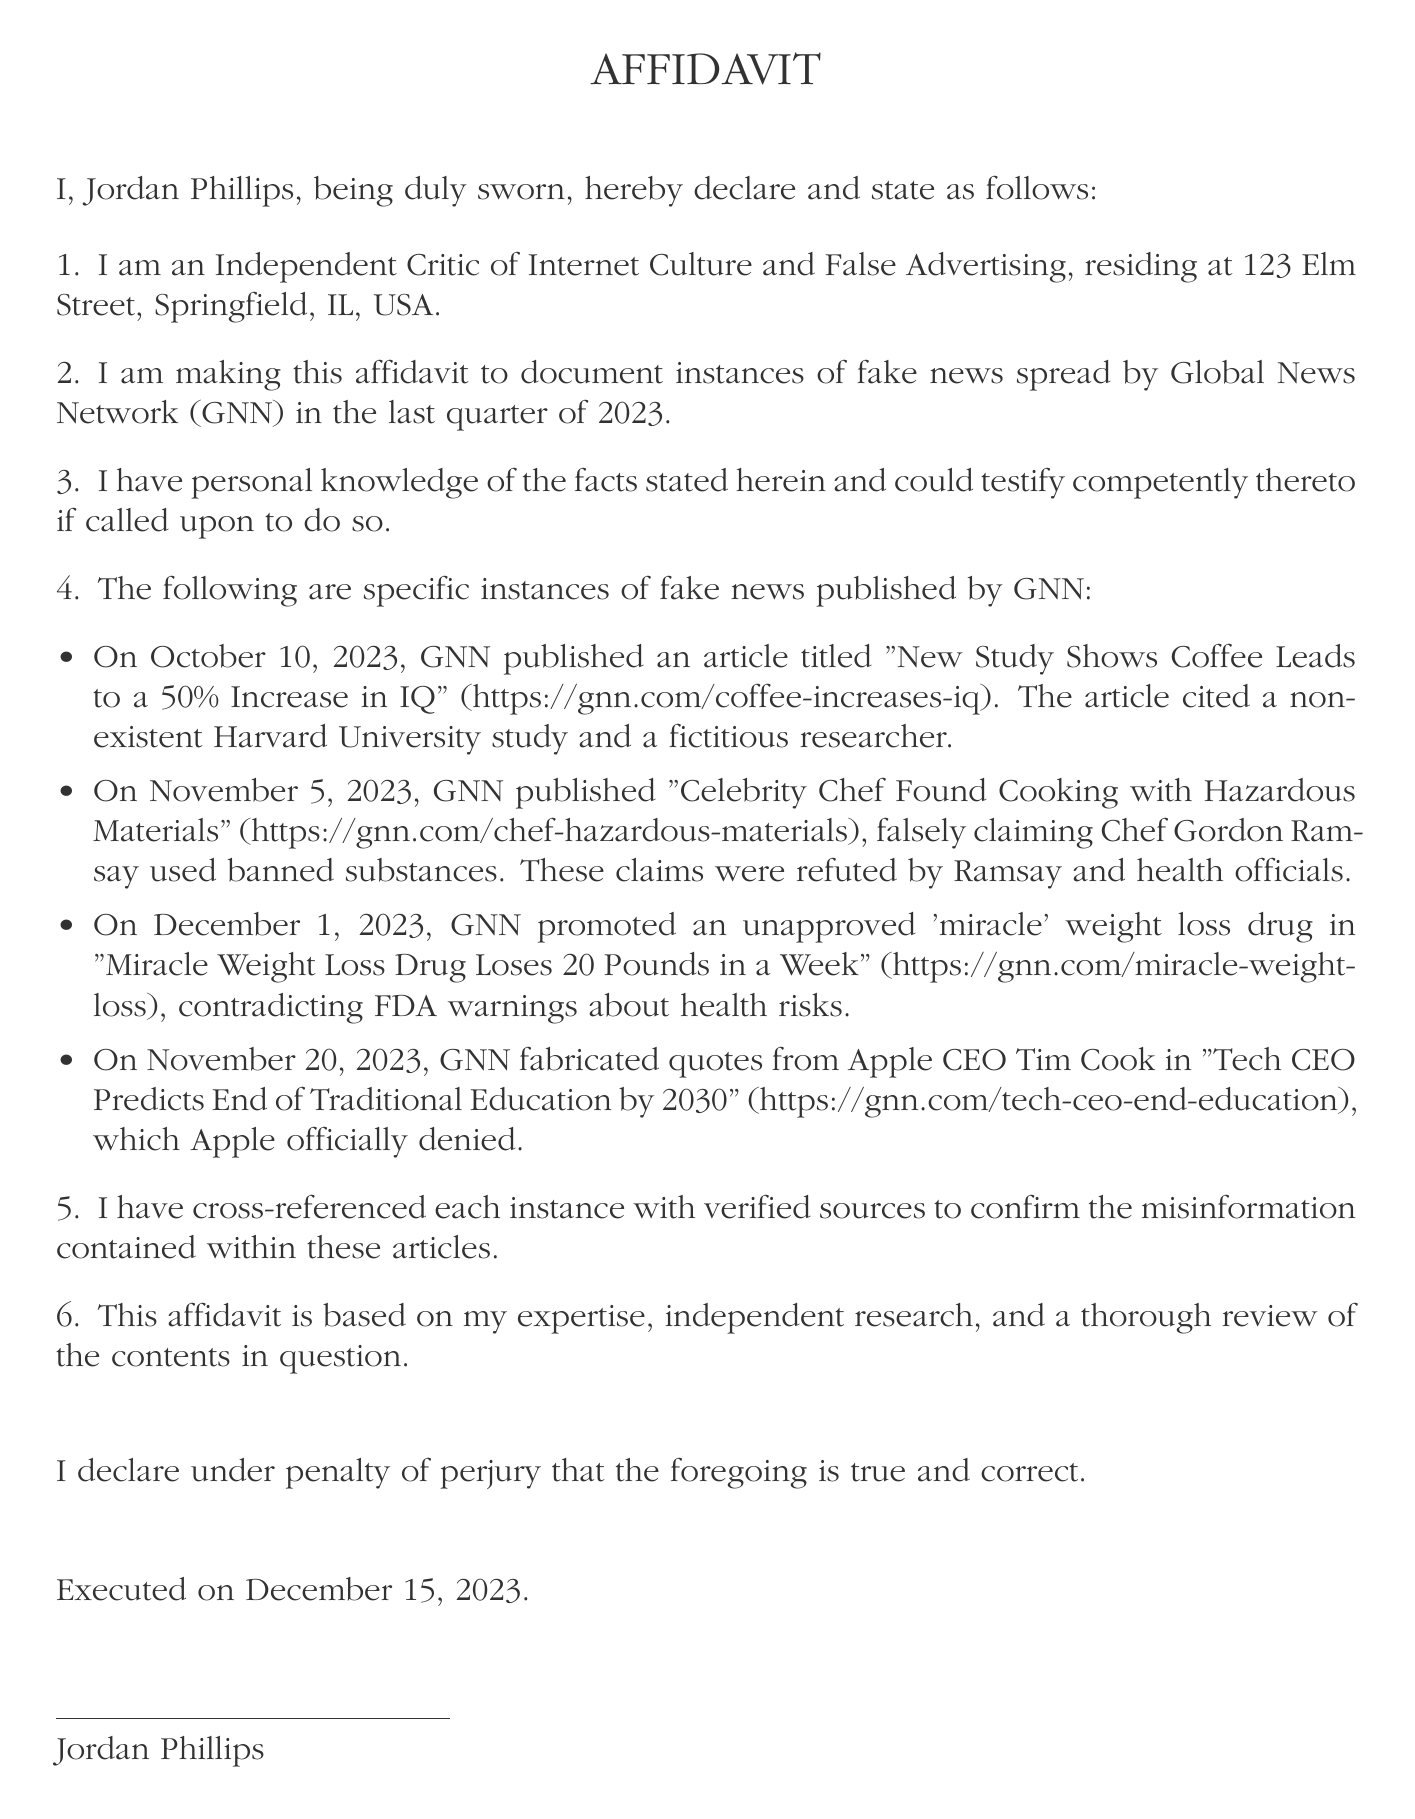What is the name of the affiant? The affiant is the person who is making the affidavit, which in this case is mentioned at the beginning of the document.
Answer: Jordan Phillips What date was the affidavit executed? The executed date is specifically mentioned in the document's final section.
Answer: December 15, 2023 How many instances of fake news are documented? The document lists specific instances of misinformation and states how many there are in the corresponding section.
Answer: Four What is the title of the article that claims a coffee leads to a 50% increase in IQ? The title of the article is provided as part of the specific misinformation listed.
Answer: New Study Shows Coffee Leads to a 50% Increase in IQ When was the article about the miracle weight loss drug published? The publication date is included with each instance of misinformation in the document.
Answer: December 1, 2023 Who is falsely claimed to have used hazardous materials? The document mentions a specific individual associated with the false claim as part of the news instances reported.
Answer: Chef Gordon Ramsay Which organization issued warnings about the 'miracle' weight loss drug? The organization warning about health risks is specified in the document in relation to the weight loss drug.
Answer: FDA What did Apple officially deny in relation to the documented instances? The document includes a fabricated claim that was officially denied by a prominent individual; the specific type of misinformation is relevant.
Answer: Fabricated quotes from Tim Cook 